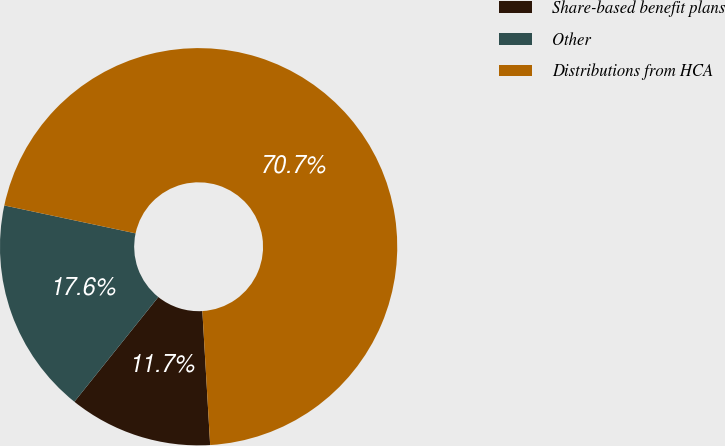Convert chart. <chart><loc_0><loc_0><loc_500><loc_500><pie_chart><fcel>Share-based benefit plans<fcel>Other<fcel>Distributions from HCA<nl><fcel>11.68%<fcel>17.58%<fcel>70.74%<nl></chart> 